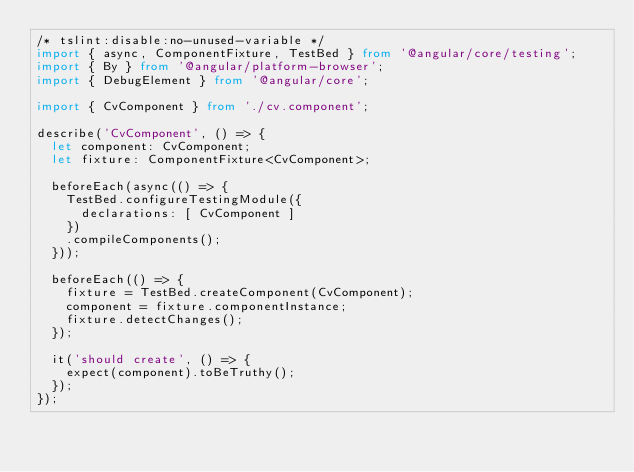<code> <loc_0><loc_0><loc_500><loc_500><_TypeScript_>/* tslint:disable:no-unused-variable */
import { async, ComponentFixture, TestBed } from '@angular/core/testing';
import { By } from '@angular/platform-browser';
import { DebugElement } from '@angular/core';

import { CvComponent } from './cv.component';

describe('CvComponent', () => {
  let component: CvComponent;
  let fixture: ComponentFixture<CvComponent>;

  beforeEach(async(() => {
    TestBed.configureTestingModule({
      declarations: [ CvComponent ]
    })
    .compileComponents();
  }));

  beforeEach(() => {
    fixture = TestBed.createComponent(CvComponent);
    component = fixture.componentInstance;
    fixture.detectChanges();
  });

  it('should create', () => {
    expect(component).toBeTruthy();
  });
});
</code> 